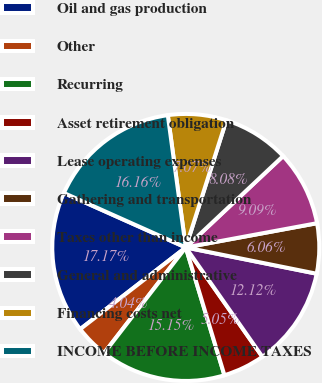Convert chart to OTSL. <chart><loc_0><loc_0><loc_500><loc_500><pie_chart><fcel>Oil and gas production<fcel>Other<fcel>Recurring<fcel>Asset retirement obligation<fcel>Lease operating expenses<fcel>Gathering and transportation<fcel>Taxes other than income<fcel>General and administrative<fcel>Financing costs net<fcel>INCOME BEFORE INCOME TAXES<nl><fcel>17.17%<fcel>4.04%<fcel>15.15%<fcel>5.05%<fcel>12.12%<fcel>6.06%<fcel>9.09%<fcel>8.08%<fcel>7.07%<fcel>16.16%<nl></chart> 